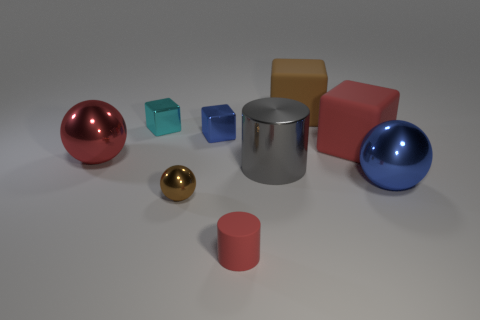Is there any other thing that is the same size as the brown matte object?
Keep it short and to the point. Yes. There is another rubber object that is the same color as the tiny matte thing; what is its shape?
Provide a succinct answer. Cube. What color is the cube that is the same size as the brown rubber thing?
Provide a succinct answer. Red. What is the color of the big ball that is right of the brown object that is behind the small metallic ball?
Provide a succinct answer. Blue. Do the big shiny thing that is behind the gray thing and the small matte thing have the same color?
Offer a very short reply. Yes. What is the shape of the big rubber object that is behind the big rubber block that is on the right side of the big object behind the tiny blue metallic object?
Offer a very short reply. Cube. There is a brown thing behind the large red metallic thing; what number of large red balls are in front of it?
Ensure brevity in your answer.  1. Do the small brown sphere and the big brown object have the same material?
Provide a short and direct response. No. There is a big sphere right of the shiny ball behind the big blue metal sphere; how many red matte blocks are behind it?
Keep it short and to the point. 1. There is a metallic cube in front of the cyan shiny object; what is its color?
Keep it short and to the point. Blue. 